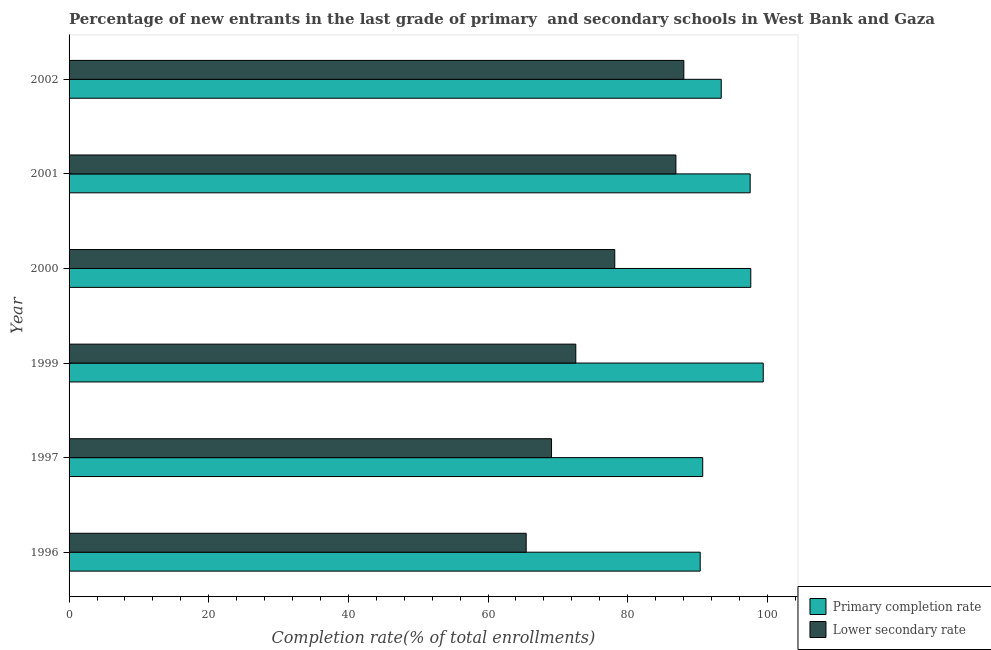How many groups of bars are there?
Keep it short and to the point. 6. Are the number of bars on each tick of the Y-axis equal?
Offer a terse response. Yes. How many bars are there on the 1st tick from the bottom?
Provide a succinct answer. 2. What is the completion rate in secondary schools in 2002?
Give a very brief answer. 88.05. Across all years, what is the maximum completion rate in secondary schools?
Keep it short and to the point. 88.05. Across all years, what is the minimum completion rate in primary schools?
Offer a very short reply. 90.39. In which year was the completion rate in primary schools maximum?
Your answer should be compact. 1999. In which year was the completion rate in secondary schools minimum?
Your answer should be very brief. 1996. What is the total completion rate in secondary schools in the graph?
Your response must be concise. 460.26. What is the difference between the completion rate in primary schools in 2000 and that in 2002?
Give a very brief answer. 4.23. What is the difference between the completion rate in secondary schools in 1997 and the completion rate in primary schools in 1996?
Offer a very short reply. -21.29. What is the average completion rate in secondary schools per year?
Offer a terse response. 76.71. In the year 1999, what is the difference between the completion rate in primary schools and completion rate in secondary schools?
Offer a very short reply. 26.85. What is the ratio of the completion rate in primary schools in 1997 to that in 2002?
Give a very brief answer. 0.97. Is the difference between the completion rate in primary schools in 2001 and 2002 greater than the difference between the completion rate in secondary schools in 2001 and 2002?
Offer a very short reply. Yes. What is the difference between the highest and the second highest completion rate in secondary schools?
Offer a terse response. 1.14. What is the difference between the highest and the lowest completion rate in primary schools?
Your response must be concise. 9.03. In how many years, is the completion rate in secondary schools greater than the average completion rate in secondary schools taken over all years?
Ensure brevity in your answer.  3. What does the 2nd bar from the top in 1999 represents?
Ensure brevity in your answer.  Primary completion rate. What does the 2nd bar from the bottom in 2000 represents?
Keep it short and to the point. Lower secondary rate. How many years are there in the graph?
Offer a very short reply. 6. What is the difference between two consecutive major ticks on the X-axis?
Make the answer very short. 20. Does the graph contain any zero values?
Your answer should be compact. No. How many legend labels are there?
Provide a short and direct response. 2. What is the title of the graph?
Give a very brief answer. Percentage of new entrants in the last grade of primary  and secondary schools in West Bank and Gaza. Does "Death rate" appear as one of the legend labels in the graph?
Provide a short and direct response. No. What is the label or title of the X-axis?
Your answer should be very brief. Completion rate(% of total enrollments). What is the label or title of the Y-axis?
Keep it short and to the point. Year. What is the Completion rate(% of total enrollments) in Primary completion rate in 1996?
Provide a short and direct response. 90.39. What is the Completion rate(% of total enrollments) of Lower secondary rate in 1996?
Your response must be concise. 65.47. What is the Completion rate(% of total enrollments) of Primary completion rate in 1997?
Your answer should be compact. 90.75. What is the Completion rate(% of total enrollments) of Lower secondary rate in 1997?
Ensure brevity in your answer.  69.1. What is the Completion rate(% of total enrollments) of Primary completion rate in 1999?
Your answer should be compact. 99.42. What is the Completion rate(% of total enrollments) in Lower secondary rate in 1999?
Offer a terse response. 72.57. What is the Completion rate(% of total enrollments) of Primary completion rate in 2000?
Make the answer very short. 97.64. What is the Completion rate(% of total enrollments) in Lower secondary rate in 2000?
Give a very brief answer. 78.15. What is the Completion rate(% of total enrollments) in Primary completion rate in 2001?
Provide a short and direct response. 97.55. What is the Completion rate(% of total enrollments) in Lower secondary rate in 2001?
Your response must be concise. 86.91. What is the Completion rate(% of total enrollments) of Primary completion rate in 2002?
Your answer should be compact. 93.41. What is the Completion rate(% of total enrollments) of Lower secondary rate in 2002?
Make the answer very short. 88.05. Across all years, what is the maximum Completion rate(% of total enrollments) of Primary completion rate?
Give a very brief answer. 99.42. Across all years, what is the maximum Completion rate(% of total enrollments) in Lower secondary rate?
Your answer should be very brief. 88.05. Across all years, what is the minimum Completion rate(% of total enrollments) in Primary completion rate?
Make the answer very short. 90.39. Across all years, what is the minimum Completion rate(% of total enrollments) of Lower secondary rate?
Make the answer very short. 65.47. What is the total Completion rate(% of total enrollments) of Primary completion rate in the graph?
Your answer should be compact. 569.16. What is the total Completion rate(% of total enrollments) in Lower secondary rate in the graph?
Keep it short and to the point. 460.26. What is the difference between the Completion rate(% of total enrollments) in Primary completion rate in 1996 and that in 1997?
Keep it short and to the point. -0.36. What is the difference between the Completion rate(% of total enrollments) in Lower secondary rate in 1996 and that in 1997?
Your answer should be very brief. -3.63. What is the difference between the Completion rate(% of total enrollments) of Primary completion rate in 1996 and that in 1999?
Make the answer very short. -9.03. What is the difference between the Completion rate(% of total enrollments) of Lower secondary rate in 1996 and that in 1999?
Offer a terse response. -7.11. What is the difference between the Completion rate(% of total enrollments) in Primary completion rate in 1996 and that in 2000?
Provide a short and direct response. -7.25. What is the difference between the Completion rate(% of total enrollments) in Lower secondary rate in 1996 and that in 2000?
Your response must be concise. -12.69. What is the difference between the Completion rate(% of total enrollments) in Primary completion rate in 1996 and that in 2001?
Ensure brevity in your answer.  -7.16. What is the difference between the Completion rate(% of total enrollments) in Lower secondary rate in 1996 and that in 2001?
Give a very brief answer. -21.44. What is the difference between the Completion rate(% of total enrollments) of Primary completion rate in 1996 and that in 2002?
Your answer should be very brief. -3.02. What is the difference between the Completion rate(% of total enrollments) in Lower secondary rate in 1996 and that in 2002?
Provide a succinct answer. -22.58. What is the difference between the Completion rate(% of total enrollments) in Primary completion rate in 1997 and that in 1999?
Make the answer very short. -8.67. What is the difference between the Completion rate(% of total enrollments) of Lower secondary rate in 1997 and that in 1999?
Keep it short and to the point. -3.47. What is the difference between the Completion rate(% of total enrollments) in Primary completion rate in 1997 and that in 2000?
Make the answer very short. -6.88. What is the difference between the Completion rate(% of total enrollments) in Lower secondary rate in 1997 and that in 2000?
Provide a succinct answer. -9.05. What is the difference between the Completion rate(% of total enrollments) in Primary completion rate in 1997 and that in 2001?
Offer a very short reply. -6.8. What is the difference between the Completion rate(% of total enrollments) of Lower secondary rate in 1997 and that in 2001?
Your response must be concise. -17.81. What is the difference between the Completion rate(% of total enrollments) in Primary completion rate in 1997 and that in 2002?
Ensure brevity in your answer.  -2.65. What is the difference between the Completion rate(% of total enrollments) of Lower secondary rate in 1997 and that in 2002?
Keep it short and to the point. -18.95. What is the difference between the Completion rate(% of total enrollments) in Primary completion rate in 1999 and that in 2000?
Give a very brief answer. 1.78. What is the difference between the Completion rate(% of total enrollments) of Lower secondary rate in 1999 and that in 2000?
Keep it short and to the point. -5.58. What is the difference between the Completion rate(% of total enrollments) in Primary completion rate in 1999 and that in 2001?
Provide a short and direct response. 1.87. What is the difference between the Completion rate(% of total enrollments) of Lower secondary rate in 1999 and that in 2001?
Your answer should be very brief. -14.34. What is the difference between the Completion rate(% of total enrollments) in Primary completion rate in 1999 and that in 2002?
Your answer should be very brief. 6.01. What is the difference between the Completion rate(% of total enrollments) in Lower secondary rate in 1999 and that in 2002?
Provide a succinct answer. -15.48. What is the difference between the Completion rate(% of total enrollments) of Primary completion rate in 2000 and that in 2001?
Provide a short and direct response. 0.09. What is the difference between the Completion rate(% of total enrollments) in Lower secondary rate in 2000 and that in 2001?
Your answer should be very brief. -8.76. What is the difference between the Completion rate(% of total enrollments) in Primary completion rate in 2000 and that in 2002?
Your response must be concise. 4.23. What is the difference between the Completion rate(% of total enrollments) of Lower secondary rate in 2000 and that in 2002?
Offer a terse response. -9.89. What is the difference between the Completion rate(% of total enrollments) of Primary completion rate in 2001 and that in 2002?
Offer a very short reply. 4.14. What is the difference between the Completion rate(% of total enrollments) of Lower secondary rate in 2001 and that in 2002?
Offer a very short reply. -1.14. What is the difference between the Completion rate(% of total enrollments) in Primary completion rate in 1996 and the Completion rate(% of total enrollments) in Lower secondary rate in 1997?
Ensure brevity in your answer.  21.29. What is the difference between the Completion rate(% of total enrollments) in Primary completion rate in 1996 and the Completion rate(% of total enrollments) in Lower secondary rate in 1999?
Offer a terse response. 17.82. What is the difference between the Completion rate(% of total enrollments) of Primary completion rate in 1996 and the Completion rate(% of total enrollments) of Lower secondary rate in 2000?
Your answer should be very brief. 12.24. What is the difference between the Completion rate(% of total enrollments) in Primary completion rate in 1996 and the Completion rate(% of total enrollments) in Lower secondary rate in 2001?
Give a very brief answer. 3.48. What is the difference between the Completion rate(% of total enrollments) in Primary completion rate in 1996 and the Completion rate(% of total enrollments) in Lower secondary rate in 2002?
Offer a terse response. 2.34. What is the difference between the Completion rate(% of total enrollments) in Primary completion rate in 1997 and the Completion rate(% of total enrollments) in Lower secondary rate in 1999?
Offer a very short reply. 18.18. What is the difference between the Completion rate(% of total enrollments) in Primary completion rate in 1997 and the Completion rate(% of total enrollments) in Lower secondary rate in 2000?
Ensure brevity in your answer.  12.6. What is the difference between the Completion rate(% of total enrollments) in Primary completion rate in 1997 and the Completion rate(% of total enrollments) in Lower secondary rate in 2001?
Provide a short and direct response. 3.84. What is the difference between the Completion rate(% of total enrollments) in Primary completion rate in 1997 and the Completion rate(% of total enrollments) in Lower secondary rate in 2002?
Your response must be concise. 2.7. What is the difference between the Completion rate(% of total enrollments) of Primary completion rate in 1999 and the Completion rate(% of total enrollments) of Lower secondary rate in 2000?
Offer a terse response. 21.27. What is the difference between the Completion rate(% of total enrollments) in Primary completion rate in 1999 and the Completion rate(% of total enrollments) in Lower secondary rate in 2001?
Provide a short and direct response. 12.51. What is the difference between the Completion rate(% of total enrollments) of Primary completion rate in 1999 and the Completion rate(% of total enrollments) of Lower secondary rate in 2002?
Provide a short and direct response. 11.37. What is the difference between the Completion rate(% of total enrollments) in Primary completion rate in 2000 and the Completion rate(% of total enrollments) in Lower secondary rate in 2001?
Give a very brief answer. 10.73. What is the difference between the Completion rate(% of total enrollments) in Primary completion rate in 2000 and the Completion rate(% of total enrollments) in Lower secondary rate in 2002?
Give a very brief answer. 9.59. What is the difference between the Completion rate(% of total enrollments) in Primary completion rate in 2001 and the Completion rate(% of total enrollments) in Lower secondary rate in 2002?
Keep it short and to the point. 9.5. What is the average Completion rate(% of total enrollments) in Primary completion rate per year?
Keep it short and to the point. 94.86. What is the average Completion rate(% of total enrollments) in Lower secondary rate per year?
Your response must be concise. 76.71. In the year 1996, what is the difference between the Completion rate(% of total enrollments) in Primary completion rate and Completion rate(% of total enrollments) in Lower secondary rate?
Your answer should be compact. 24.92. In the year 1997, what is the difference between the Completion rate(% of total enrollments) of Primary completion rate and Completion rate(% of total enrollments) of Lower secondary rate?
Your answer should be very brief. 21.65. In the year 1999, what is the difference between the Completion rate(% of total enrollments) of Primary completion rate and Completion rate(% of total enrollments) of Lower secondary rate?
Your answer should be very brief. 26.85. In the year 2000, what is the difference between the Completion rate(% of total enrollments) of Primary completion rate and Completion rate(% of total enrollments) of Lower secondary rate?
Provide a short and direct response. 19.48. In the year 2001, what is the difference between the Completion rate(% of total enrollments) of Primary completion rate and Completion rate(% of total enrollments) of Lower secondary rate?
Your response must be concise. 10.64. In the year 2002, what is the difference between the Completion rate(% of total enrollments) in Primary completion rate and Completion rate(% of total enrollments) in Lower secondary rate?
Offer a very short reply. 5.36. What is the ratio of the Completion rate(% of total enrollments) in Primary completion rate in 1996 to that in 1997?
Make the answer very short. 1. What is the ratio of the Completion rate(% of total enrollments) in Primary completion rate in 1996 to that in 1999?
Provide a short and direct response. 0.91. What is the ratio of the Completion rate(% of total enrollments) of Lower secondary rate in 1996 to that in 1999?
Keep it short and to the point. 0.9. What is the ratio of the Completion rate(% of total enrollments) of Primary completion rate in 1996 to that in 2000?
Your answer should be compact. 0.93. What is the ratio of the Completion rate(% of total enrollments) in Lower secondary rate in 1996 to that in 2000?
Keep it short and to the point. 0.84. What is the ratio of the Completion rate(% of total enrollments) in Primary completion rate in 1996 to that in 2001?
Give a very brief answer. 0.93. What is the ratio of the Completion rate(% of total enrollments) of Lower secondary rate in 1996 to that in 2001?
Provide a short and direct response. 0.75. What is the ratio of the Completion rate(% of total enrollments) in Lower secondary rate in 1996 to that in 2002?
Make the answer very short. 0.74. What is the ratio of the Completion rate(% of total enrollments) in Primary completion rate in 1997 to that in 1999?
Offer a very short reply. 0.91. What is the ratio of the Completion rate(% of total enrollments) of Lower secondary rate in 1997 to that in 1999?
Provide a short and direct response. 0.95. What is the ratio of the Completion rate(% of total enrollments) in Primary completion rate in 1997 to that in 2000?
Ensure brevity in your answer.  0.93. What is the ratio of the Completion rate(% of total enrollments) in Lower secondary rate in 1997 to that in 2000?
Offer a very short reply. 0.88. What is the ratio of the Completion rate(% of total enrollments) of Primary completion rate in 1997 to that in 2001?
Keep it short and to the point. 0.93. What is the ratio of the Completion rate(% of total enrollments) of Lower secondary rate in 1997 to that in 2001?
Provide a short and direct response. 0.8. What is the ratio of the Completion rate(% of total enrollments) of Primary completion rate in 1997 to that in 2002?
Ensure brevity in your answer.  0.97. What is the ratio of the Completion rate(% of total enrollments) of Lower secondary rate in 1997 to that in 2002?
Give a very brief answer. 0.78. What is the ratio of the Completion rate(% of total enrollments) in Primary completion rate in 1999 to that in 2000?
Keep it short and to the point. 1.02. What is the ratio of the Completion rate(% of total enrollments) in Primary completion rate in 1999 to that in 2001?
Give a very brief answer. 1.02. What is the ratio of the Completion rate(% of total enrollments) of Lower secondary rate in 1999 to that in 2001?
Keep it short and to the point. 0.83. What is the ratio of the Completion rate(% of total enrollments) in Primary completion rate in 1999 to that in 2002?
Your response must be concise. 1.06. What is the ratio of the Completion rate(% of total enrollments) in Lower secondary rate in 1999 to that in 2002?
Keep it short and to the point. 0.82. What is the ratio of the Completion rate(% of total enrollments) of Lower secondary rate in 2000 to that in 2001?
Keep it short and to the point. 0.9. What is the ratio of the Completion rate(% of total enrollments) of Primary completion rate in 2000 to that in 2002?
Ensure brevity in your answer.  1.05. What is the ratio of the Completion rate(% of total enrollments) of Lower secondary rate in 2000 to that in 2002?
Make the answer very short. 0.89. What is the ratio of the Completion rate(% of total enrollments) in Primary completion rate in 2001 to that in 2002?
Keep it short and to the point. 1.04. What is the ratio of the Completion rate(% of total enrollments) in Lower secondary rate in 2001 to that in 2002?
Ensure brevity in your answer.  0.99. What is the difference between the highest and the second highest Completion rate(% of total enrollments) of Primary completion rate?
Offer a terse response. 1.78. What is the difference between the highest and the second highest Completion rate(% of total enrollments) in Lower secondary rate?
Provide a short and direct response. 1.14. What is the difference between the highest and the lowest Completion rate(% of total enrollments) of Primary completion rate?
Make the answer very short. 9.03. What is the difference between the highest and the lowest Completion rate(% of total enrollments) in Lower secondary rate?
Provide a succinct answer. 22.58. 